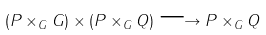Convert formula to latex. <formula><loc_0><loc_0><loc_500><loc_500>( P \times _ { G } G ) \times ( P \times _ { G } Q ) \longrightarrow P \times _ { G } Q</formula> 